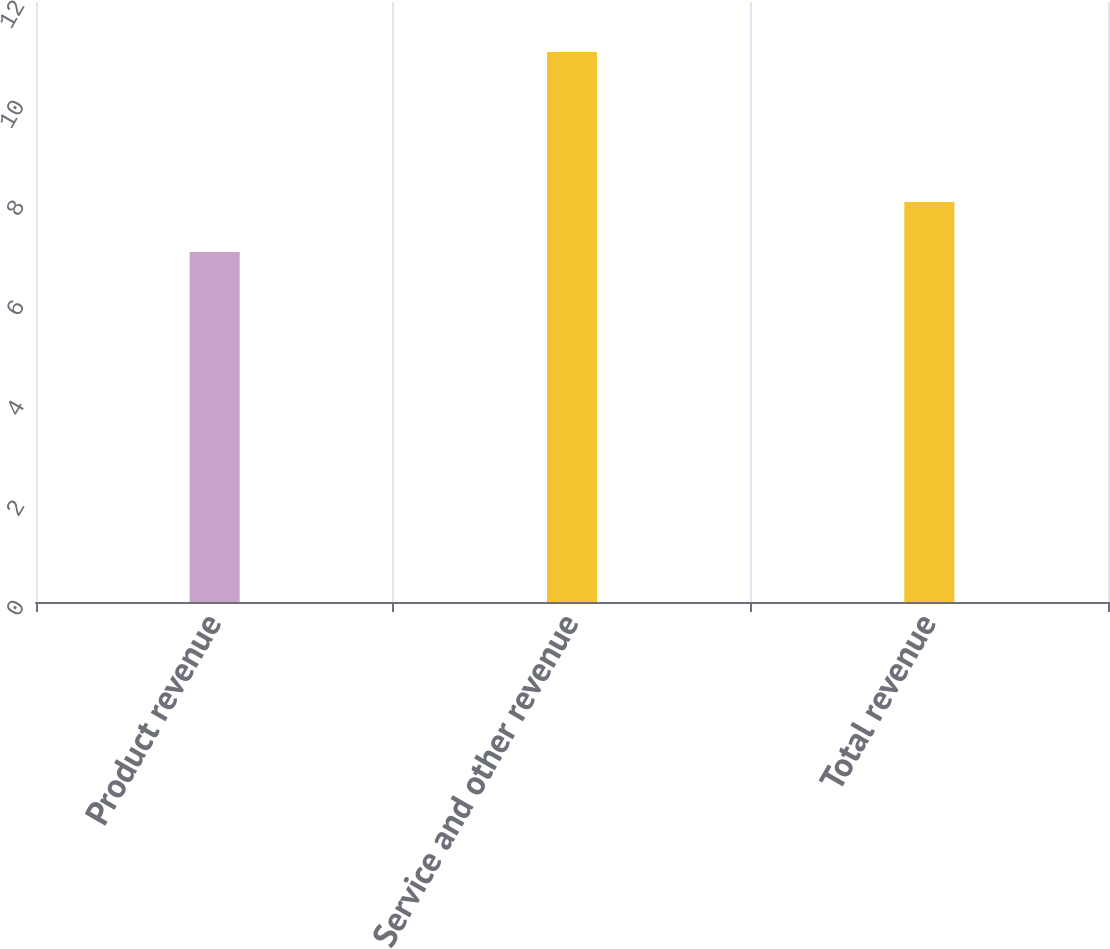Convert chart. <chart><loc_0><loc_0><loc_500><loc_500><bar_chart><fcel>Product revenue<fcel>Service and other revenue<fcel>Total revenue<nl><fcel>7<fcel>11<fcel>8<nl></chart> 